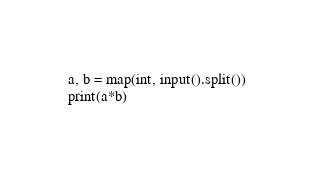<code> <loc_0><loc_0><loc_500><loc_500><_Python_>a, b = map(int, input().split())
print(a*b)</code> 